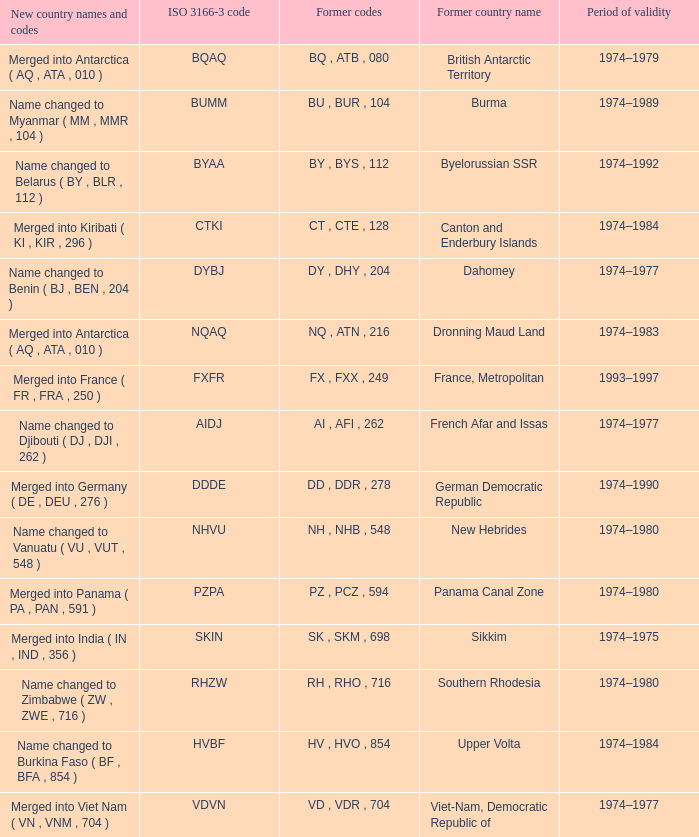Name the former codes for  merged into panama ( pa , pan , 591 ) PZ , PCZ , 594. Could you parse the entire table? {'header': ['New country names and codes', 'ISO 3166-3 code', 'Former codes', 'Former country name', 'Period of validity'], 'rows': [['Merged into Antarctica ( AQ , ATA , 010 )', 'BQAQ', 'BQ , ATB , 080', 'British Antarctic Territory', '1974–1979'], ['Name changed to Myanmar ( MM , MMR , 104 )', 'BUMM', 'BU , BUR , 104', 'Burma', '1974–1989'], ['Name changed to Belarus ( BY , BLR , 112 )', 'BYAA', 'BY , BYS , 112', 'Byelorussian SSR', '1974–1992'], ['Merged into Kiribati ( KI , KIR , 296 )', 'CTKI', 'CT , CTE , 128', 'Canton and Enderbury Islands', '1974–1984'], ['Name changed to Benin ( BJ , BEN , 204 )', 'DYBJ', 'DY , DHY , 204', 'Dahomey', '1974–1977'], ['Merged into Antarctica ( AQ , ATA , 010 )', 'NQAQ', 'NQ , ATN , 216', 'Dronning Maud Land', '1974–1983'], ['Merged into France ( FR , FRA , 250 )', 'FXFR', 'FX , FXX , 249', 'France, Metropolitan', '1993–1997'], ['Name changed to Djibouti ( DJ , DJI , 262 )', 'AIDJ', 'AI , AFI , 262', 'French Afar and Issas', '1974–1977'], ['Merged into Germany ( DE , DEU , 276 )', 'DDDE', 'DD , DDR , 278', 'German Democratic Republic', '1974–1990'], ['Name changed to Vanuatu ( VU , VUT , 548 )', 'NHVU', 'NH , NHB , 548', 'New Hebrides', '1974–1980'], ['Merged into Panama ( PA , PAN , 591 )', 'PZPA', 'PZ , PCZ , 594', 'Panama Canal Zone', '1974–1980'], ['Merged into India ( IN , IND , 356 )', 'SKIN', 'SK , SKM , 698', 'Sikkim', '1974–1975'], ['Name changed to Zimbabwe ( ZW , ZWE , 716 )', 'RHZW', 'RH , RHO , 716', 'Southern Rhodesia', '1974–1980'], ['Name changed to Burkina Faso ( BF , BFA , 854 )', 'HVBF', 'HV , HVO , 854', 'Upper Volta', '1974–1984'], ['Merged into Viet Nam ( VN , VNM , 704 )', 'VDVN', 'VD , VDR , 704', 'Viet-Nam, Democratic Republic of', '1974–1977']]} 